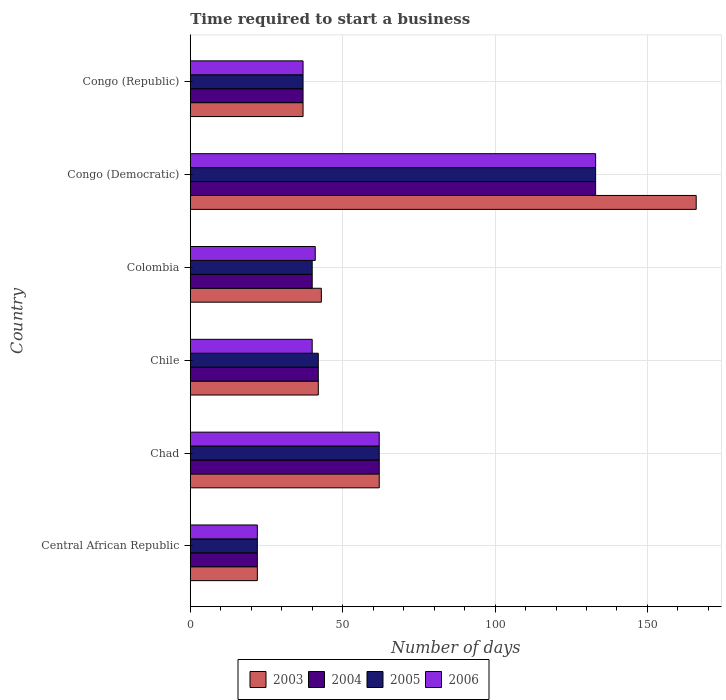How many different coloured bars are there?
Provide a short and direct response. 4. Are the number of bars per tick equal to the number of legend labels?
Provide a short and direct response. Yes. Are the number of bars on each tick of the Y-axis equal?
Ensure brevity in your answer.  Yes. How many bars are there on the 3rd tick from the top?
Offer a very short reply. 4. What is the label of the 2nd group of bars from the top?
Ensure brevity in your answer.  Congo (Democratic). In how many cases, is the number of bars for a given country not equal to the number of legend labels?
Offer a very short reply. 0. Across all countries, what is the maximum number of days required to start a business in 2005?
Ensure brevity in your answer.  133. Across all countries, what is the minimum number of days required to start a business in 2003?
Your response must be concise. 22. In which country was the number of days required to start a business in 2006 maximum?
Keep it short and to the point. Congo (Democratic). In which country was the number of days required to start a business in 2003 minimum?
Make the answer very short. Central African Republic. What is the total number of days required to start a business in 2005 in the graph?
Offer a very short reply. 336. What is the difference between the number of days required to start a business in 2004 in Central African Republic and that in Congo (Democratic)?
Offer a terse response. -111. What is the difference between the number of days required to start a business in 2006 in Chad and the number of days required to start a business in 2003 in Congo (Democratic)?
Your answer should be compact. -104. What is the average number of days required to start a business in 2005 per country?
Offer a terse response. 56. What is the ratio of the number of days required to start a business in 2004 in Chile to that in Congo (Democratic)?
Your answer should be very brief. 0.32. Is the number of days required to start a business in 2005 in Central African Republic less than that in Chile?
Give a very brief answer. Yes. What is the difference between the highest and the lowest number of days required to start a business in 2003?
Offer a terse response. 144. Is it the case that in every country, the sum of the number of days required to start a business in 2003 and number of days required to start a business in 2005 is greater than the sum of number of days required to start a business in 2004 and number of days required to start a business in 2006?
Provide a short and direct response. No. What does the 2nd bar from the bottom in Congo (Republic) represents?
Offer a terse response. 2004. Is it the case that in every country, the sum of the number of days required to start a business in 2004 and number of days required to start a business in 2005 is greater than the number of days required to start a business in 2003?
Offer a very short reply. Yes. How many bars are there?
Offer a terse response. 24. How many countries are there in the graph?
Offer a very short reply. 6. Does the graph contain any zero values?
Make the answer very short. No. Does the graph contain grids?
Your response must be concise. Yes. Where does the legend appear in the graph?
Your response must be concise. Bottom center. What is the title of the graph?
Provide a short and direct response. Time required to start a business. What is the label or title of the X-axis?
Offer a very short reply. Number of days. What is the Number of days of 2003 in Central African Republic?
Offer a very short reply. 22. What is the Number of days of 2004 in Central African Republic?
Ensure brevity in your answer.  22. What is the Number of days of 2003 in Chad?
Ensure brevity in your answer.  62. What is the Number of days of 2004 in Chad?
Make the answer very short. 62. What is the Number of days in 2005 in Chad?
Your answer should be compact. 62. What is the Number of days of 2006 in Chad?
Provide a succinct answer. 62. What is the Number of days in 2005 in Chile?
Your answer should be very brief. 42. What is the Number of days of 2003 in Congo (Democratic)?
Your answer should be very brief. 166. What is the Number of days of 2004 in Congo (Democratic)?
Make the answer very short. 133. What is the Number of days in 2005 in Congo (Democratic)?
Provide a short and direct response. 133. What is the Number of days in 2006 in Congo (Democratic)?
Ensure brevity in your answer.  133. What is the Number of days in 2004 in Congo (Republic)?
Ensure brevity in your answer.  37. What is the Number of days in 2005 in Congo (Republic)?
Ensure brevity in your answer.  37. Across all countries, what is the maximum Number of days of 2003?
Provide a succinct answer. 166. Across all countries, what is the maximum Number of days in 2004?
Your response must be concise. 133. Across all countries, what is the maximum Number of days in 2005?
Offer a terse response. 133. Across all countries, what is the maximum Number of days in 2006?
Your response must be concise. 133. Across all countries, what is the minimum Number of days of 2003?
Your answer should be very brief. 22. Across all countries, what is the minimum Number of days of 2005?
Keep it short and to the point. 22. Across all countries, what is the minimum Number of days in 2006?
Ensure brevity in your answer.  22. What is the total Number of days of 2003 in the graph?
Your answer should be compact. 372. What is the total Number of days of 2004 in the graph?
Your answer should be very brief. 336. What is the total Number of days in 2005 in the graph?
Make the answer very short. 336. What is the total Number of days in 2006 in the graph?
Provide a succinct answer. 335. What is the difference between the Number of days in 2004 in Central African Republic and that in Chad?
Make the answer very short. -40. What is the difference between the Number of days in 2005 in Central African Republic and that in Chad?
Your response must be concise. -40. What is the difference between the Number of days of 2005 in Central African Republic and that in Chile?
Ensure brevity in your answer.  -20. What is the difference between the Number of days of 2006 in Central African Republic and that in Chile?
Provide a short and direct response. -18. What is the difference between the Number of days of 2003 in Central African Republic and that in Colombia?
Ensure brevity in your answer.  -21. What is the difference between the Number of days of 2003 in Central African Republic and that in Congo (Democratic)?
Your response must be concise. -144. What is the difference between the Number of days of 2004 in Central African Republic and that in Congo (Democratic)?
Ensure brevity in your answer.  -111. What is the difference between the Number of days of 2005 in Central African Republic and that in Congo (Democratic)?
Offer a very short reply. -111. What is the difference between the Number of days in 2006 in Central African Republic and that in Congo (Democratic)?
Provide a short and direct response. -111. What is the difference between the Number of days of 2005 in Central African Republic and that in Congo (Republic)?
Ensure brevity in your answer.  -15. What is the difference between the Number of days of 2005 in Chad and that in Chile?
Offer a terse response. 20. What is the difference between the Number of days in 2004 in Chad and that in Colombia?
Ensure brevity in your answer.  22. What is the difference between the Number of days of 2005 in Chad and that in Colombia?
Your answer should be very brief. 22. What is the difference between the Number of days in 2003 in Chad and that in Congo (Democratic)?
Make the answer very short. -104. What is the difference between the Number of days of 2004 in Chad and that in Congo (Democratic)?
Provide a succinct answer. -71. What is the difference between the Number of days of 2005 in Chad and that in Congo (Democratic)?
Your answer should be very brief. -71. What is the difference between the Number of days of 2006 in Chad and that in Congo (Democratic)?
Ensure brevity in your answer.  -71. What is the difference between the Number of days in 2003 in Chad and that in Congo (Republic)?
Make the answer very short. 25. What is the difference between the Number of days in 2005 in Chad and that in Congo (Republic)?
Your answer should be compact. 25. What is the difference between the Number of days of 2004 in Chile and that in Colombia?
Ensure brevity in your answer.  2. What is the difference between the Number of days of 2005 in Chile and that in Colombia?
Keep it short and to the point. 2. What is the difference between the Number of days of 2003 in Chile and that in Congo (Democratic)?
Keep it short and to the point. -124. What is the difference between the Number of days of 2004 in Chile and that in Congo (Democratic)?
Ensure brevity in your answer.  -91. What is the difference between the Number of days of 2005 in Chile and that in Congo (Democratic)?
Make the answer very short. -91. What is the difference between the Number of days in 2006 in Chile and that in Congo (Democratic)?
Ensure brevity in your answer.  -93. What is the difference between the Number of days of 2004 in Chile and that in Congo (Republic)?
Offer a terse response. 5. What is the difference between the Number of days in 2003 in Colombia and that in Congo (Democratic)?
Keep it short and to the point. -123. What is the difference between the Number of days in 2004 in Colombia and that in Congo (Democratic)?
Your answer should be very brief. -93. What is the difference between the Number of days in 2005 in Colombia and that in Congo (Democratic)?
Your response must be concise. -93. What is the difference between the Number of days of 2006 in Colombia and that in Congo (Democratic)?
Make the answer very short. -92. What is the difference between the Number of days of 2003 in Colombia and that in Congo (Republic)?
Your answer should be compact. 6. What is the difference between the Number of days of 2004 in Colombia and that in Congo (Republic)?
Offer a terse response. 3. What is the difference between the Number of days in 2003 in Congo (Democratic) and that in Congo (Republic)?
Offer a very short reply. 129. What is the difference between the Number of days in 2004 in Congo (Democratic) and that in Congo (Republic)?
Make the answer very short. 96. What is the difference between the Number of days of 2005 in Congo (Democratic) and that in Congo (Republic)?
Your answer should be compact. 96. What is the difference between the Number of days in 2006 in Congo (Democratic) and that in Congo (Republic)?
Offer a terse response. 96. What is the difference between the Number of days in 2003 in Central African Republic and the Number of days in 2004 in Chad?
Offer a very short reply. -40. What is the difference between the Number of days in 2003 in Central African Republic and the Number of days in 2006 in Chad?
Keep it short and to the point. -40. What is the difference between the Number of days in 2003 in Central African Republic and the Number of days in 2004 in Chile?
Make the answer very short. -20. What is the difference between the Number of days of 2003 in Central African Republic and the Number of days of 2005 in Chile?
Offer a terse response. -20. What is the difference between the Number of days in 2003 in Central African Republic and the Number of days in 2006 in Chile?
Your answer should be compact. -18. What is the difference between the Number of days in 2005 in Central African Republic and the Number of days in 2006 in Chile?
Your answer should be very brief. -18. What is the difference between the Number of days of 2003 in Central African Republic and the Number of days of 2005 in Colombia?
Ensure brevity in your answer.  -18. What is the difference between the Number of days of 2003 in Central African Republic and the Number of days of 2004 in Congo (Democratic)?
Your answer should be very brief. -111. What is the difference between the Number of days of 2003 in Central African Republic and the Number of days of 2005 in Congo (Democratic)?
Ensure brevity in your answer.  -111. What is the difference between the Number of days of 2003 in Central African Republic and the Number of days of 2006 in Congo (Democratic)?
Offer a very short reply. -111. What is the difference between the Number of days in 2004 in Central African Republic and the Number of days in 2005 in Congo (Democratic)?
Your response must be concise. -111. What is the difference between the Number of days in 2004 in Central African Republic and the Number of days in 2006 in Congo (Democratic)?
Make the answer very short. -111. What is the difference between the Number of days in 2005 in Central African Republic and the Number of days in 2006 in Congo (Democratic)?
Provide a succinct answer. -111. What is the difference between the Number of days of 2003 in Central African Republic and the Number of days of 2004 in Congo (Republic)?
Provide a short and direct response. -15. What is the difference between the Number of days in 2003 in Central African Republic and the Number of days in 2005 in Congo (Republic)?
Your answer should be compact. -15. What is the difference between the Number of days of 2003 in Central African Republic and the Number of days of 2006 in Congo (Republic)?
Make the answer very short. -15. What is the difference between the Number of days in 2004 in Chad and the Number of days in 2005 in Chile?
Your answer should be very brief. 20. What is the difference between the Number of days of 2004 in Chad and the Number of days of 2006 in Chile?
Ensure brevity in your answer.  22. What is the difference between the Number of days of 2003 in Chad and the Number of days of 2004 in Colombia?
Ensure brevity in your answer.  22. What is the difference between the Number of days of 2004 in Chad and the Number of days of 2006 in Colombia?
Offer a very short reply. 21. What is the difference between the Number of days in 2003 in Chad and the Number of days in 2004 in Congo (Democratic)?
Your response must be concise. -71. What is the difference between the Number of days in 2003 in Chad and the Number of days in 2005 in Congo (Democratic)?
Give a very brief answer. -71. What is the difference between the Number of days of 2003 in Chad and the Number of days of 2006 in Congo (Democratic)?
Make the answer very short. -71. What is the difference between the Number of days of 2004 in Chad and the Number of days of 2005 in Congo (Democratic)?
Your answer should be very brief. -71. What is the difference between the Number of days in 2004 in Chad and the Number of days in 2006 in Congo (Democratic)?
Your answer should be compact. -71. What is the difference between the Number of days in 2005 in Chad and the Number of days in 2006 in Congo (Democratic)?
Provide a succinct answer. -71. What is the difference between the Number of days of 2003 in Chile and the Number of days of 2006 in Colombia?
Offer a terse response. 1. What is the difference between the Number of days in 2004 in Chile and the Number of days in 2005 in Colombia?
Your response must be concise. 2. What is the difference between the Number of days in 2004 in Chile and the Number of days in 2006 in Colombia?
Offer a very short reply. 1. What is the difference between the Number of days in 2003 in Chile and the Number of days in 2004 in Congo (Democratic)?
Your response must be concise. -91. What is the difference between the Number of days of 2003 in Chile and the Number of days of 2005 in Congo (Democratic)?
Keep it short and to the point. -91. What is the difference between the Number of days of 2003 in Chile and the Number of days of 2006 in Congo (Democratic)?
Provide a succinct answer. -91. What is the difference between the Number of days in 2004 in Chile and the Number of days in 2005 in Congo (Democratic)?
Make the answer very short. -91. What is the difference between the Number of days in 2004 in Chile and the Number of days in 2006 in Congo (Democratic)?
Provide a succinct answer. -91. What is the difference between the Number of days of 2005 in Chile and the Number of days of 2006 in Congo (Democratic)?
Ensure brevity in your answer.  -91. What is the difference between the Number of days of 2004 in Chile and the Number of days of 2005 in Congo (Republic)?
Your answer should be very brief. 5. What is the difference between the Number of days in 2004 in Chile and the Number of days in 2006 in Congo (Republic)?
Keep it short and to the point. 5. What is the difference between the Number of days in 2003 in Colombia and the Number of days in 2004 in Congo (Democratic)?
Keep it short and to the point. -90. What is the difference between the Number of days in 2003 in Colombia and the Number of days in 2005 in Congo (Democratic)?
Your answer should be compact. -90. What is the difference between the Number of days in 2003 in Colombia and the Number of days in 2006 in Congo (Democratic)?
Ensure brevity in your answer.  -90. What is the difference between the Number of days in 2004 in Colombia and the Number of days in 2005 in Congo (Democratic)?
Give a very brief answer. -93. What is the difference between the Number of days of 2004 in Colombia and the Number of days of 2006 in Congo (Democratic)?
Offer a terse response. -93. What is the difference between the Number of days of 2005 in Colombia and the Number of days of 2006 in Congo (Democratic)?
Provide a succinct answer. -93. What is the difference between the Number of days in 2005 in Colombia and the Number of days in 2006 in Congo (Republic)?
Offer a terse response. 3. What is the difference between the Number of days of 2003 in Congo (Democratic) and the Number of days of 2004 in Congo (Republic)?
Provide a short and direct response. 129. What is the difference between the Number of days of 2003 in Congo (Democratic) and the Number of days of 2005 in Congo (Republic)?
Your answer should be very brief. 129. What is the difference between the Number of days of 2003 in Congo (Democratic) and the Number of days of 2006 in Congo (Republic)?
Provide a short and direct response. 129. What is the difference between the Number of days in 2004 in Congo (Democratic) and the Number of days in 2005 in Congo (Republic)?
Provide a short and direct response. 96. What is the difference between the Number of days in 2004 in Congo (Democratic) and the Number of days in 2006 in Congo (Republic)?
Give a very brief answer. 96. What is the difference between the Number of days of 2005 in Congo (Democratic) and the Number of days of 2006 in Congo (Republic)?
Make the answer very short. 96. What is the average Number of days in 2003 per country?
Give a very brief answer. 62. What is the average Number of days in 2004 per country?
Offer a terse response. 56. What is the average Number of days of 2005 per country?
Offer a very short reply. 56. What is the average Number of days in 2006 per country?
Your answer should be very brief. 55.83. What is the difference between the Number of days in 2003 and Number of days in 2004 in Central African Republic?
Provide a succinct answer. 0. What is the difference between the Number of days of 2003 and Number of days of 2006 in Central African Republic?
Offer a terse response. 0. What is the difference between the Number of days of 2004 and Number of days of 2005 in Central African Republic?
Your answer should be very brief. 0. What is the difference between the Number of days of 2005 and Number of days of 2006 in Chad?
Your answer should be very brief. 0. What is the difference between the Number of days of 2003 and Number of days of 2006 in Chile?
Provide a short and direct response. 2. What is the difference between the Number of days of 2004 and Number of days of 2006 in Chile?
Offer a very short reply. 2. What is the difference between the Number of days of 2003 and Number of days of 2006 in Colombia?
Give a very brief answer. 2. What is the difference between the Number of days of 2004 and Number of days of 2005 in Colombia?
Provide a succinct answer. 0. What is the difference between the Number of days in 2005 and Number of days in 2006 in Colombia?
Give a very brief answer. -1. What is the difference between the Number of days in 2003 and Number of days in 2006 in Congo (Democratic)?
Provide a short and direct response. 33. What is the difference between the Number of days in 2003 and Number of days in 2005 in Congo (Republic)?
Offer a very short reply. 0. What is the difference between the Number of days in 2003 and Number of days in 2006 in Congo (Republic)?
Your answer should be compact. 0. What is the difference between the Number of days in 2004 and Number of days in 2005 in Congo (Republic)?
Your response must be concise. 0. What is the difference between the Number of days in 2004 and Number of days in 2006 in Congo (Republic)?
Provide a succinct answer. 0. What is the difference between the Number of days of 2005 and Number of days of 2006 in Congo (Republic)?
Your answer should be compact. 0. What is the ratio of the Number of days in 2003 in Central African Republic to that in Chad?
Offer a terse response. 0.35. What is the ratio of the Number of days of 2004 in Central African Republic to that in Chad?
Keep it short and to the point. 0.35. What is the ratio of the Number of days in 2005 in Central African Republic to that in Chad?
Your response must be concise. 0.35. What is the ratio of the Number of days in 2006 in Central African Republic to that in Chad?
Make the answer very short. 0.35. What is the ratio of the Number of days in 2003 in Central African Republic to that in Chile?
Offer a terse response. 0.52. What is the ratio of the Number of days of 2004 in Central African Republic to that in Chile?
Your answer should be compact. 0.52. What is the ratio of the Number of days in 2005 in Central African Republic to that in Chile?
Offer a terse response. 0.52. What is the ratio of the Number of days of 2006 in Central African Republic to that in Chile?
Keep it short and to the point. 0.55. What is the ratio of the Number of days of 2003 in Central African Republic to that in Colombia?
Provide a short and direct response. 0.51. What is the ratio of the Number of days of 2004 in Central African Republic to that in Colombia?
Offer a terse response. 0.55. What is the ratio of the Number of days of 2005 in Central African Republic to that in Colombia?
Provide a short and direct response. 0.55. What is the ratio of the Number of days in 2006 in Central African Republic to that in Colombia?
Provide a succinct answer. 0.54. What is the ratio of the Number of days of 2003 in Central African Republic to that in Congo (Democratic)?
Your response must be concise. 0.13. What is the ratio of the Number of days of 2004 in Central African Republic to that in Congo (Democratic)?
Your answer should be compact. 0.17. What is the ratio of the Number of days of 2005 in Central African Republic to that in Congo (Democratic)?
Your response must be concise. 0.17. What is the ratio of the Number of days in 2006 in Central African Republic to that in Congo (Democratic)?
Give a very brief answer. 0.17. What is the ratio of the Number of days of 2003 in Central African Republic to that in Congo (Republic)?
Offer a terse response. 0.59. What is the ratio of the Number of days of 2004 in Central African Republic to that in Congo (Republic)?
Provide a succinct answer. 0.59. What is the ratio of the Number of days in 2005 in Central African Republic to that in Congo (Republic)?
Make the answer very short. 0.59. What is the ratio of the Number of days of 2006 in Central African Republic to that in Congo (Republic)?
Offer a very short reply. 0.59. What is the ratio of the Number of days of 2003 in Chad to that in Chile?
Your answer should be very brief. 1.48. What is the ratio of the Number of days of 2004 in Chad to that in Chile?
Your answer should be very brief. 1.48. What is the ratio of the Number of days of 2005 in Chad to that in Chile?
Your answer should be very brief. 1.48. What is the ratio of the Number of days in 2006 in Chad to that in Chile?
Keep it short and to the point. 1.55. What is the ratio of the Number of days in 2003 in Chad to that in Colombia?
Your answer should be compact. 1.44. What is the ratio of the Number of days in 2004 in Chad to that in Colombia?
Ensure brevity in your answer.  1.55. What is the ratio of the Number of days in 2005 in Chad to that in Colombia?
Your response must be concise. 1.55. What is the ratio of the Number of days of 2006 in Chad to that in Colombia?
Your answer should be very brief. 1.51. What is the ratio of the Number of days of 2003 in Chad to that in Congo (Democratic)?
Ensure brevity in your answer.  0.37. What is the ratio of the Number of days of 2004 in Chad to that in Congo (Democratic)?
Provide a succinct answer. 0.47. What is the ratio of the Number of days of 2005 in Chad to that in Congo (Democratic)?
Your answer should be very brief. 0.47. What is the ratio of the Number of days of 2006 in Chad to that in Congo (Democratic)?
Provide a succinct answer. 0.47. What is the ratio of the Number of days in 2003 in Chad to that in Congo (Republic)?
Your answer should be compact. 1.68. What is the ratio of the Number of days of 2004 in Chad to that in Congo (Republic)?
Provide a short and direct response. 1.68. What is the ratio of the Number of days in 2005 in Chad to that in Congo (Republic)?
Ensure brevity in your answer.  1.68. What is the ratio of the Number of days in 2006 in Chad to that in Congo (Republic)?
Offer a terse response. 1.68. What is the ratio of the Number of days of 2003 in Chile to that in Colombia?
Your response must be concise. 0.98. What is the ratio of the Number of days in 2005 in Chile to that in Colombia?
Keep it short and to the point. 1.05. What is the ratio of the Number of days of 2006 in Chile to that in Colombia?
Keep it short and to the point. 0.98. What is the ratio of the Number of days in 2003 in Chile to that in Congo (Democratic)?
Your response must be concise. 0.25. What is the ratio of the Number of days in 2004 in Chile to that in Congo (Democratic)?
Make the answer very short. 0.32. What is the ratio of the Number of days of 2005 in Chile to that in Congo (Democratic)?
Your response must be concise. 0.32. What is the ratio of the Number of days of 2006 in Chile to that in Congo (Democratic)?
Keep it short and to the point. 0.3. What is the ratio of the Number of days of 2003 in Chile to that in Congo (Republic)?
Your response must be concise. 1.14. What is the ratio of the Number of days of 2004 in Chile to that in Congo (Republic)?
Ensure brevity in your answer.  1.14. What is the ratio of the Number of days in 2005 in Chile to that in Congo (Republic)?
Provide a short and direct response. 1.14. What is the ratio of the Number of days in 2006 in Chile to that in Congo (Republic)?
Provide a succinct answer. 1.08. What is the ratio of the Number of days in 2003 in Colombia to that in Congo (Democratic)?
Keep it short and to the point. 0.26. What is the ratio of the Number of days in 2004 in Colombia to that in Congo (Democratic)?
Provide a succinct answer. 0.3. What is the ratio of the Number of days in 2005 in Colombia to that in Congo (Democratic)?
Give a very brief answer. 0.3. What is the ratio of the Number of days in 2006 in Colombia to that in Congo (Democratic)?
Your answer should be compact. 0.31. What is the ratio of the Number of days in 2003 in Colombia to that in Congo (Republic)?
Your answer should be compact. 1.16. What is the ratio of the Number of days in 2004 in Colombia to that in Congo (Republic)?
Provide a short and direct response. 1.08. What is the ratio of the Number of days in 2005 in Colombia to that in Congo (Republic)?
Provide a succinct answer. 1.08. What is the ratio of the Number of days of 2006 in Colombia to that in Congo (Republic)?
Keep it short and to the point. 1.11. What is the ratio of the Number of days of 2003 in Congo (Democratic) to that in Congo (Republic)?
Keep it short and to the point. 4.49. What is the ratio of the Number of days in 2004 in Congo (Democratic) to that in Congo (Republic)?
Ensure brevity in your answer.  3.59. What is the ratio of the Number of days in 2005 in Congo (Democratic) to that in Congo (Republic)?
Ensure brevity in your answer.  3.59. What is the ratio of the Number of days in 2006 in Congo (Democratic) to that in Congo (Republic)?
Offer a very short reply. 3.59. What is the difference between the highest and the second highest Number of days of 2003?
Give a very brief answer. 104. What is the difference between the highest and the second highest Number of days of 2006?
Give a very brief answer. 71. What is the difference between the highest and the lowest Number of days of 2003?
Give a very brief answer. 144. What is the difference between the highest and the lowest Number of days in 2004?
Your answer should be very brief. 111. What is the difference between the highest and the lowest Number of days of 2005?
Keep it short and to the point. 111. What is the difference between the highest and the lowest Number of days of 2006?
Your answer should be compact. 111. 